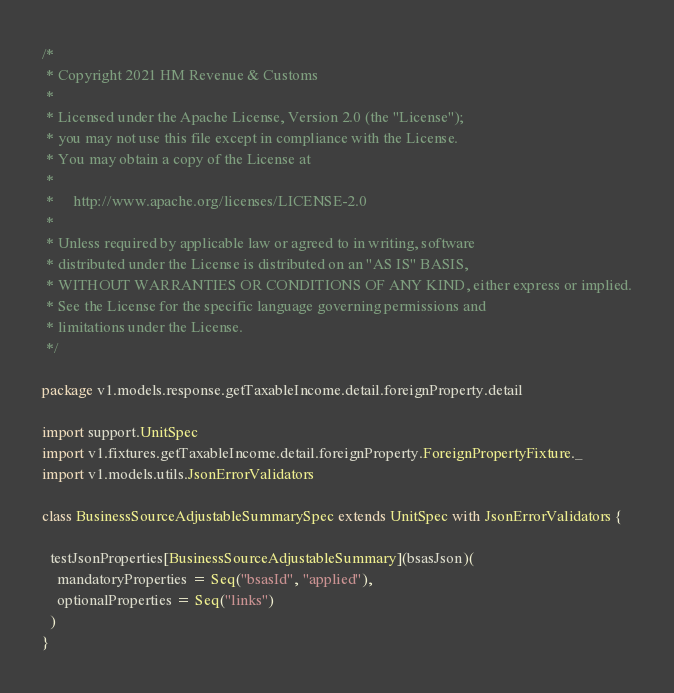<code> <loc_0><loc_0><loc_500><loc_500><_Scala_>/*
 * Copyright 2021 HM Revenue & Customs
 *
 * Licensed under the Apache License, Version 2.0 (the "License");
 * you may not use this file except in compliance with the License.
 * You may obtain a copy of the License at
 *
 *     http://www.apache.org/licenses/LICENSE-2.0
 *
 * Unless required by applicable law or agreed to in writing, software
 * distributed under the License is distributed on an "AS IS" BASIS,
 * WITHOUT WARRANTIES OR CONDITIONS OF ANY KIND, either express or implied.
 * See the License for the specific language governing permissions and
 * limitations under the License.
 */

package v1.models.response.getTaxableIncome.detail.foreignProperty.detail

import support.UnitSpec
import v1.fixtures.getTaxableIncome.detail.foreignProperty.ForeignPropertyFixture._
import v1.models.utils.JsonErrorValidators

class BusinessSourceAdjustableSummarySpec extends UnitSpec with JsonErrorValidators {

  testJsonProperties[BusinessSourceAdjustableSummary](bsasJson)(
    mandatoryProperties = Seq("bsasId", "applied"),
    optionalProperties = Seq("links")
  )
}
</code> 